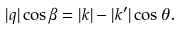Convert formula to latex. <formula><loc_0><loc_0><loc_500><loc_500>| { q } | \cos \beta = | { k } | - | { k } ^ { \prime } | \cos \theta .</formula> 